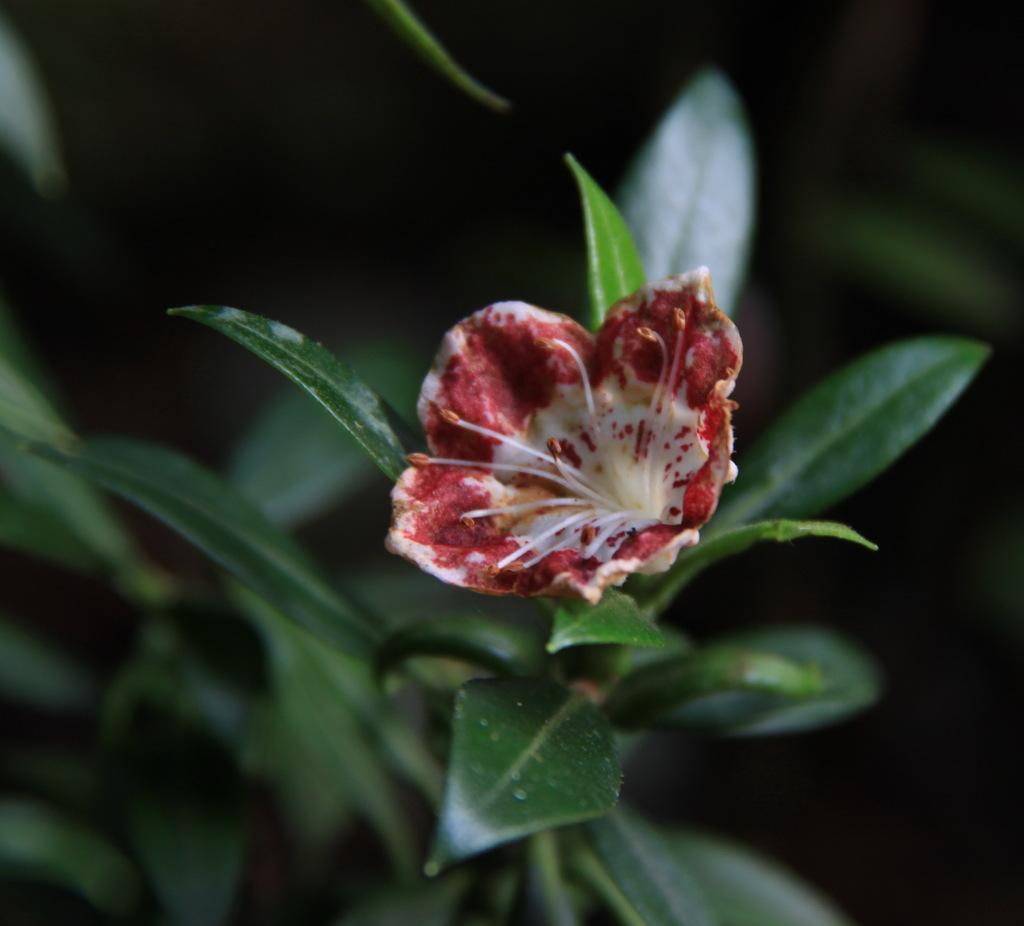What type of plant is visible in the image? There is a flower and a plant truncated in the image. Can you describe the background of the image? The background of the image is dark. What type of string is used to compare the flower and the plant in the image? There is no string present in the image, nor is there any comparison being made between the flower and the plant. 